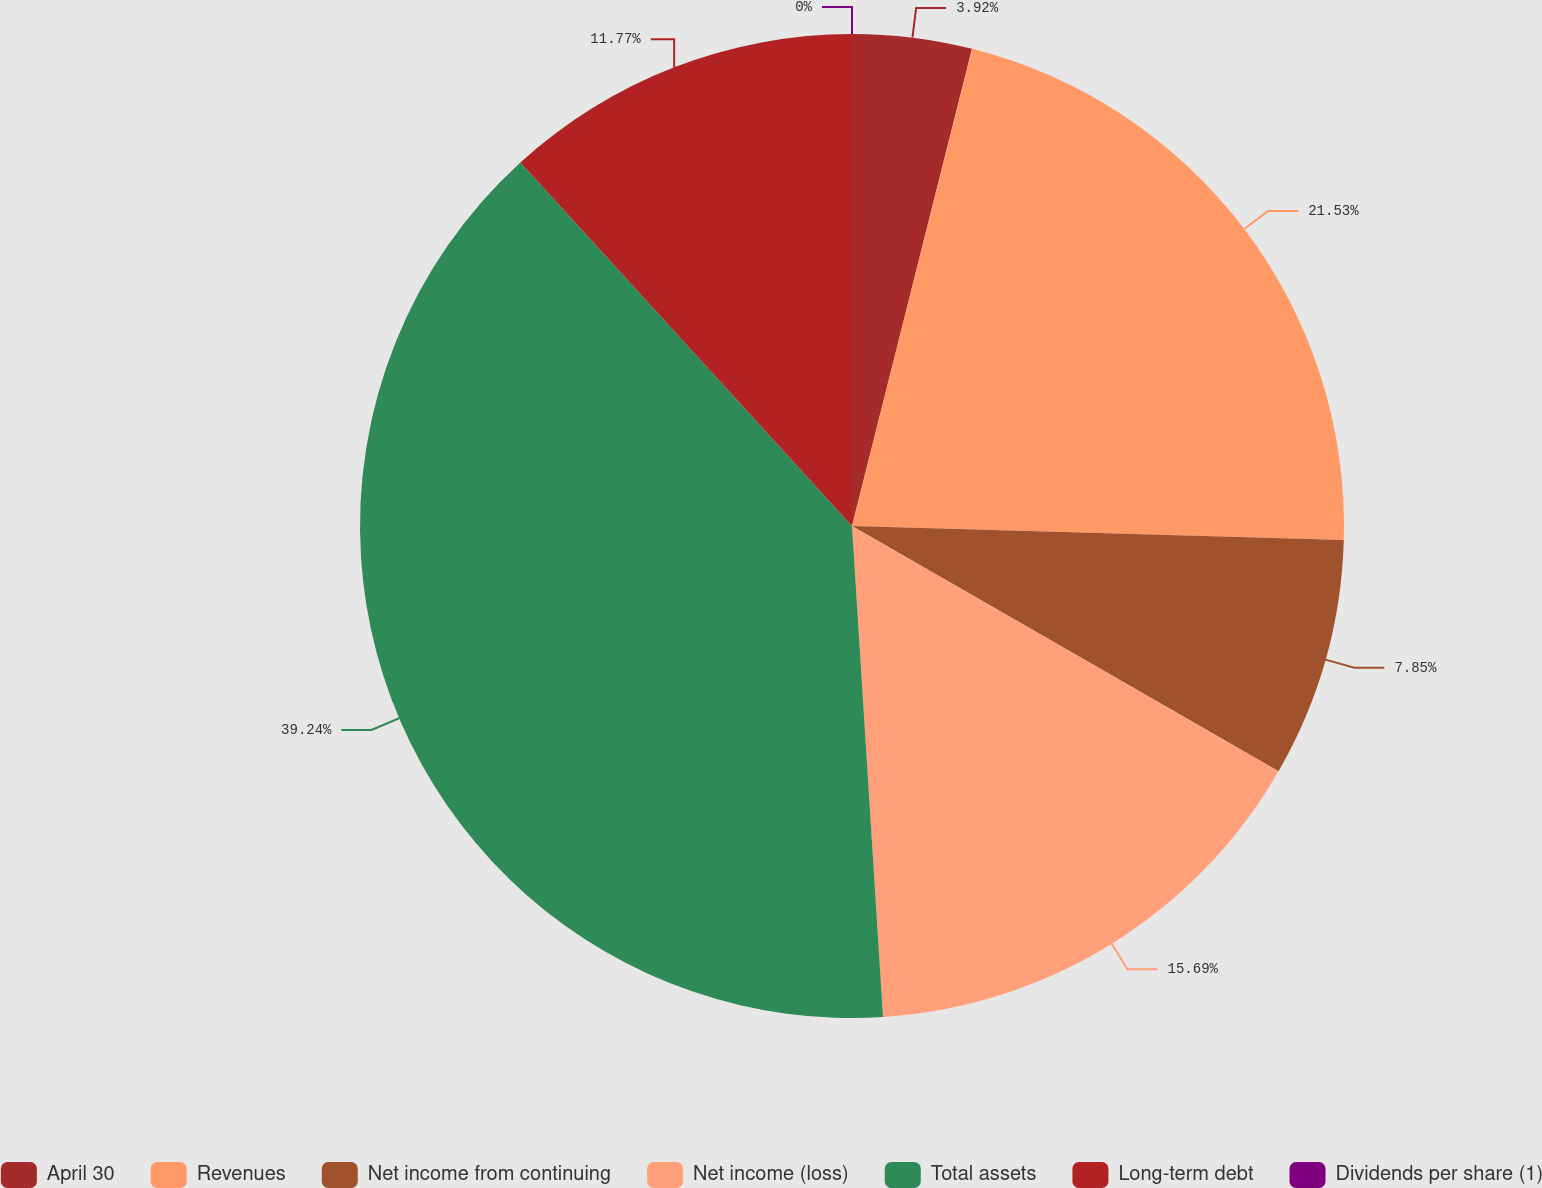<chart> <loc_0><loc_0><loc_500><loc_500><pie_chart><fcel>April 30<fcel>Revenues<fcel>Net income from continuing<fcel>Net income (loss)<fcel>Total assets<fcel>Long-term debt<fcel>Dividends per share (1)<nl><fcel>3.92%<fcel>21.53%<fcel>7.85%<fcel>15.69%<fcel>39.23%<fcel>11.77%<fcel>0.0%<nl></chart> 